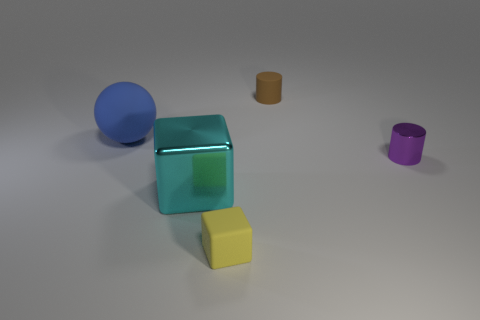Does the cylinder on the right side of the brown matte cylinder have the same size as the small yellow matte object?
Offer a terse response. Yes. How many rubber things are either large cyan cubes or large gray cylinders?
Your answer should be very brief. 0. There is a thing that is to the right of the cyan metallic object and in front of the small purple cylinder; what is its material?
Keep it short and to the point. Rubber. Does the cyan block have the same material as the yellow cube?
Give a very brief answer. No. How big is the rubber thing that is right of the ball and in front of the rubber cylinder?
Your answer should be compact. Small. The brown thing has what shape?
Provide a succinct answer. Cylinder. What number of things are either large gray shiny spheres or things in front of the blue rubber sphere?
Give a very brief answer. 3. The small thing that is to the left of the tiny metal object and behind the big cyan shiny object is what color?
Ensure brevity in your answer.  Brown. There is a cylinder that is behind the matte sphere; what is its material?
Provide a short and direct response. Rubber. How big is the rubber sphere?
Keep it short and to the point. Large. 